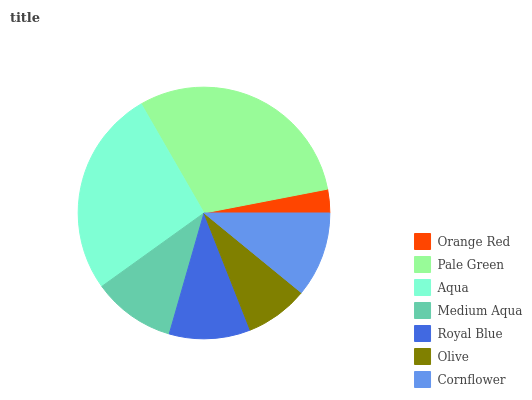Is Orange Red the minimum?
Answer yes or no. Yes. Is Pale Green the maximum?
Answer yes or no. Yes. Is Aqua the minimum?
Answer yes or no. No. Is Aqua the maximum?
Answer yes or no. No. Is Pale Green greater than Aqua?
Answer yes or no. Yes. Is Aqua less than Pale Green?
Answer yes or no. Yes. Is Aqua greater than Pale Green?
Answer yes or no. No. Is Pale Green less than Aqua?
Answer yes or no. No. Is Medium Aqua the high median?
Answer yes or no. Yes. Is Medium Aqua the low median?
Answer yes or no. Yes. Is Royal Blue the high median?
Answer yes or no. No. Is Pale Green the low median?
Answer yes or no. No. 